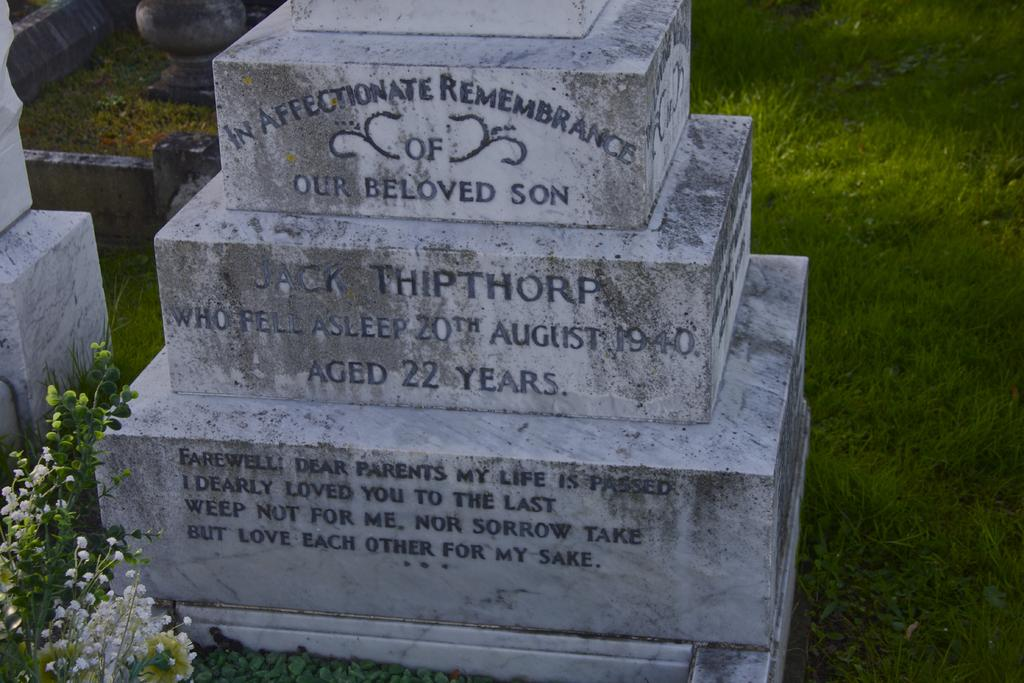What type of vegetation is present in the image? There is grass in the image. Are there any flowers visible in the image? Yes, there are white-colored flowers in the image. What color is the object in the image? The object in the image is white-colored. What is written or depicted on the white-colored object? Something is written on the white-colored object. Can you describe the shape of the sponge in the image? There is no sponge present in the image. What type of hydrant is visible in the image? There is no hydrantant present in the image. 